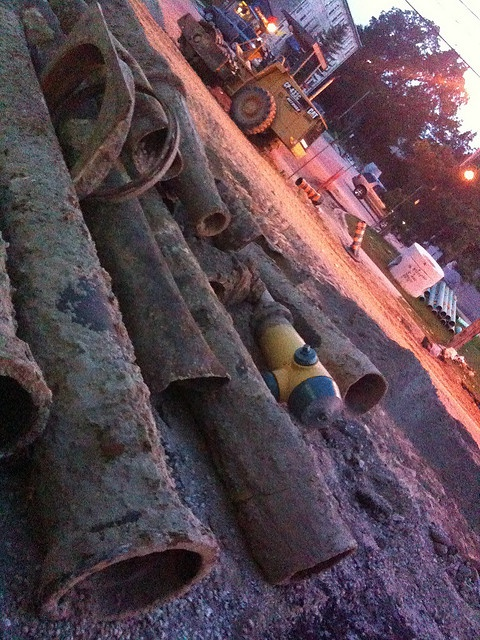Describe the objects in this image and their specific colors. I can see fire hydrant in blue, black, gray, and maroon tones, car in blue, brown, maroon, purple, and lightpink tones, and car in blue, navy, purple, and gray tones in this image. 